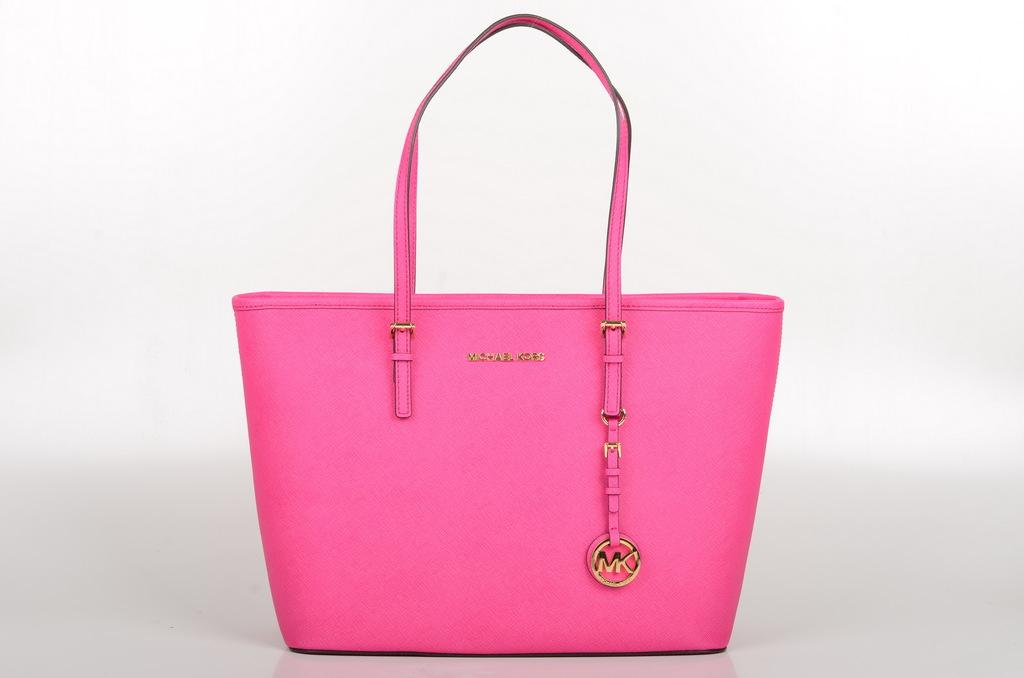What color is the handbag in the image? The handbag is pink in color. Can you hear the horn of the rabbit in the image? There is no rabbit or horn present in the image; it only features a pink handbag. 